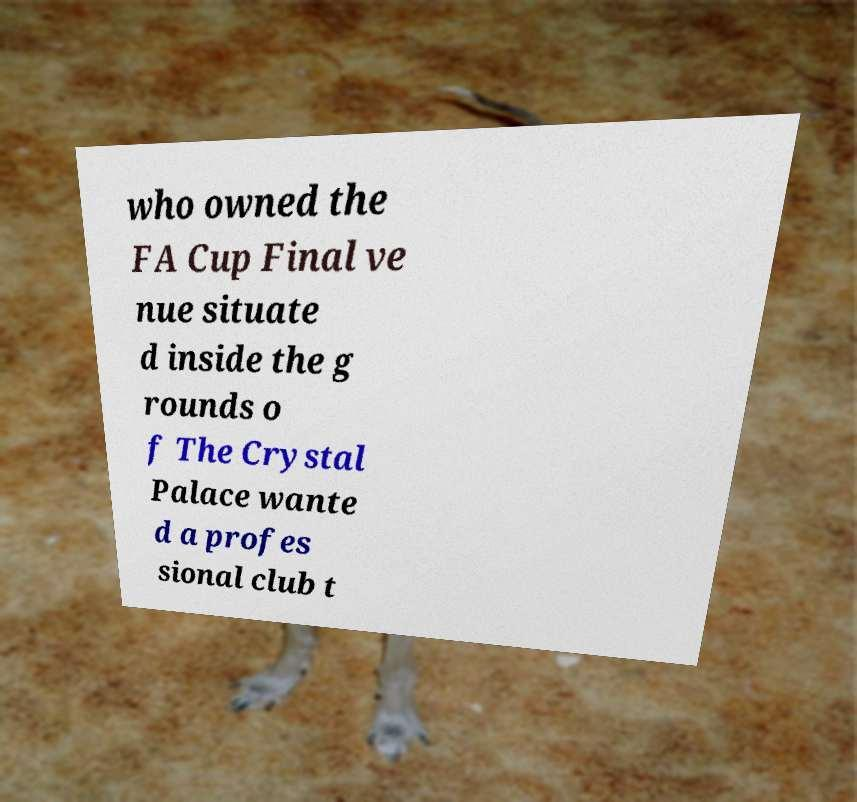Please identify and transcribe the text found in this image. who owned the FA Cup Final ve nue situate d inside the g rounds o f The Crystal Palace wante d a profes sional club t 